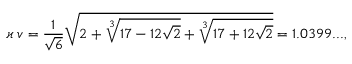Convert formula to latex. <formula><loc_0><loc_0><loc_500><loc_500>\varkappa \, v = \frac { 1 } { \sqrt { 6 } } \sqrt { 2 + \sqrt { [ } 3 ] { 1 7 - 1 2 \sqrt { 2 } } + \sqrt { [ } 3 ] { 1 7 + 1 2 \sqrt { 2 } } } = 1 . 0 3 9 9 \dots ,</formula> 